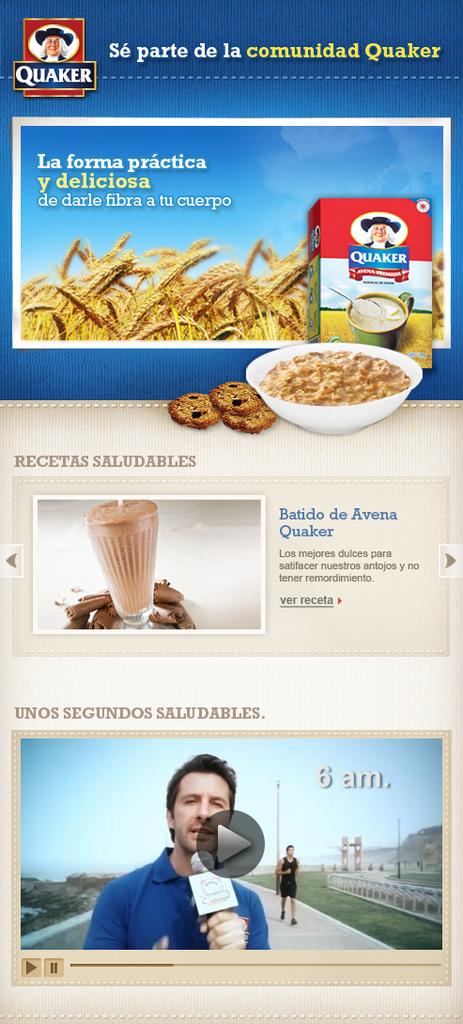What can be found in the image that contains written information? There is text in the image. What type of landscape is visible in the image? There is a field in the image. What type of items can be seen in the image that are typically consumed? There are food items in the image. Can you identify any living beings in the image? Yes, there are people in the image. What else can be seen in the image besides the mentioned elements? There are various objects in the image. How many bushes are present in the image? There is no mention of bushes in the provided facts, so we cannot determine the number of bushes in the image. What type of button can be seen in the image? There is no button mentioned in the provided facts, so we cannot determine if there is a button in the image. 